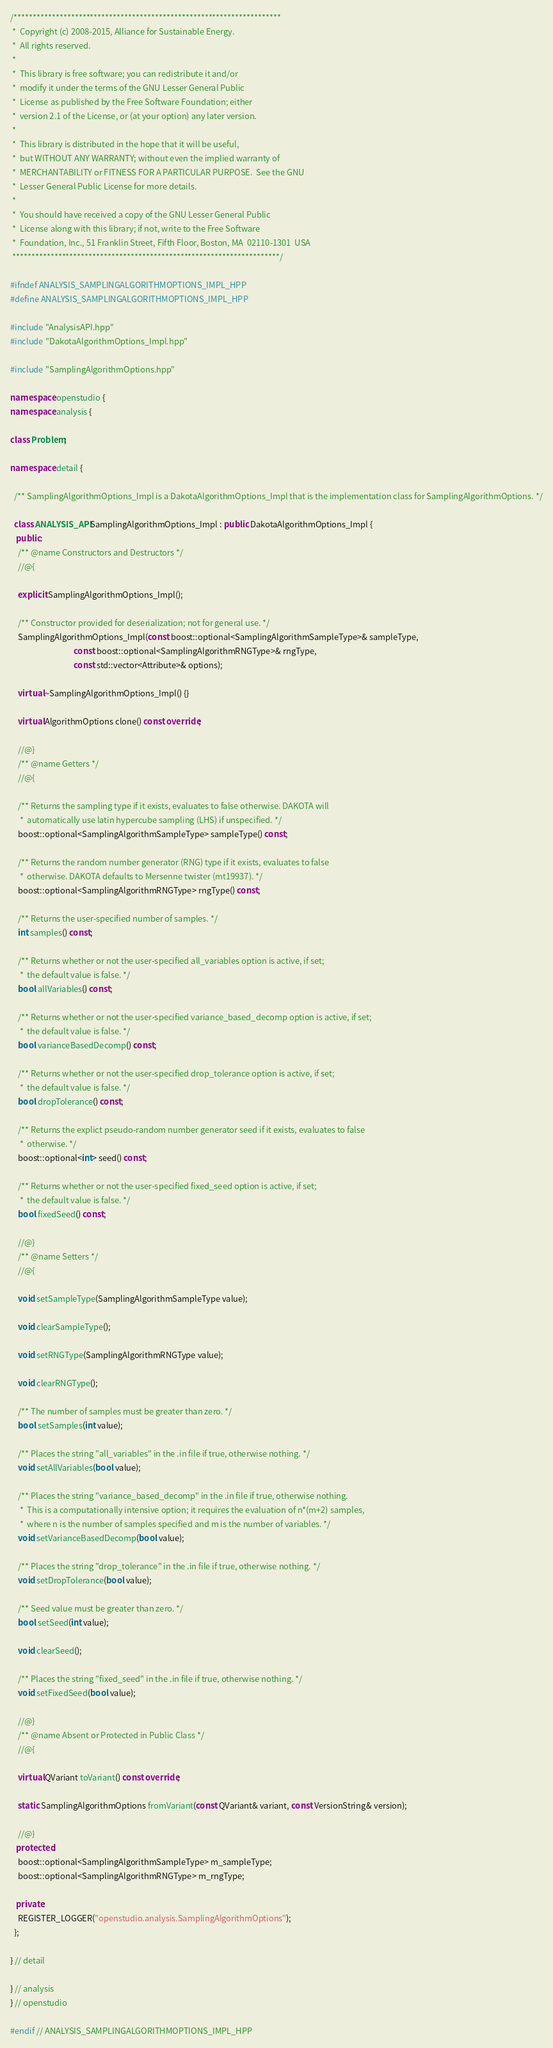<code> <loc_0><loc_0><loc_500><loc_500><_C++_>/**********************************************************************
 *  Copyright (c) 2008-2015, Alliance for Sustainable Energy.
 *  All rights reserved.
 *
 *  This library is free software; you can redistribute it and/or
 *  modify it under the terms of the GNU Lesser General Public
 *  License as published by the Free Software Foundation; either
 *  version 2.1 of the License, or (at your option) any later version.
 *
 *  This library is distributed in the hope that it will be useful,
 *  but WITHOUT ANY WARRANTY; without even the implied warranty of
 *  MERCHANTABILITY or FITNESS FOR A PARTICULAR PURPOSE.  See the GNU
 *  Lesser General Public License for more details.
 *
 *  You should have received a copy of the GNU Lesser General Public
 *  License along with this library; if not, write to the Free Software
 *  Foundation, Inc., 51 Franklin Street, Fifth Floor, Boston, MA  02110-1301  USA
 **********************************************************************/

#ifndef ANALYSIS_SAMPLINGALGORITHMOPTIONS_IMPL_HPP
#define ANALYSIS_SAMPLINGALGORITHMOPTIONS_IMPL_HPP

#include "AnalysisAPI.hpp"
#include "DakotaAlgorithmOptions_Impl.hpp"

#include "SamplingAlgorithmOptions.hpp"

namespace openstudio {
namespace analysis {

class Problem;

namespace detail {

  /** SamplingAlgorithmOptions_Impl is a DakotaAlgorithmOptions_Impl that is the implementation class for SamplingAlgorithmOptions. */

  class ANALYSIS_API SamplingAlgorithmOptions_Impl : public DakotaAlgorithmOptions_Impl {
   public:
    /** @name Constructors and Destructors */
    //@{

    explicit SamplingAlgorithmOptions_Impl();

    /** Constructor provided for deserialization; not for general use. */
    SamplingAlgorithmOptions_Impl(const boost::optional<SamplingAlgorithmSampleType>& sampleType,
                                  const boost::optional<SamplingAlgorithmRNGType>& rngType,
                                  const std::vector<Attribute>& options);

    virtual ~SamplingAlgorithmOptions_Impl() {}

    virtual AlgorithmOptions clone() const override;

    //@}
    /** @name Getters */
    //@{

    /** Returns the sampling type if it exists, evaluates to false otherwise. DAKOTA will 
     *  automatically use latin hypercube sampling (LHS) if unspecified. */
    boost::optional<SamplingAlgorithmSampleType> sampleType() const;

    /** Returns the random number generator (RNG) type if it exists, evaluates to false 
     *  otherwise. DAKOTA defaults to Mersenne twister (mt19937). */
    boost::optional<SamplingAlgorithmRNGType> rngType() const;

    /** Returns the user-specified number of samples. */
    int samples() const;

    /** Returns whether or not the user-specified all_variables option is active, if set;
     *  the default value is false. */
    bool allVariables() const;

    /** Returns whether or not the user-specified variance_based_decomp option is active, if set;
     *  the default value is false. */
    bool varianceBasedDecomp() const;

    /** Returns whether or not the user-specified drop_tolerance option is active, if set;
     *  the default value is false. */
    bool dropTolerance() const;

    /** Returns the explict pseudo-random number generator seed if it exists, evaluates to false 
     *  otherwise. */
    boost::optional<int> seed() const;

    /** Returns whether or not the user-specified fixed_seed option is active, if set;
     *  the default value is false. */
    bool fixedSeed() const;

    //@}
    /** @name Setters */
    //@{
  
    void setSampleType(SamplingAlgorithmSampleType value);
  
    void clearSampleType();   
  
    void setRNGType(SamplingAlgorithmRNGType value);
  
    void clearRNGType();   

    /** The number of samples must be greater than zero. */
    bool setSamples(int value);

    /** Places the string "all_variables" in the .in file if true, otherwise nothing. */
    void setAllVariables(bool value);
  
    /** Places the string "variance_based_decomp" in the .in file if true, otherwise nothing.
     *  This is a computationally intensive option; it requires the evaluation of n*(m+2) samples,
     *  where n is the number of samples specified and m is the number of variables. */
    void setVarianceBasedDecomp(bool value);

    /** Places the string "drop_tolerance" in the .in file if true, otherwise nothing. */
    void setDropTolerance(bool value);

    /** Seed value must be greater than zero. */
    bool setSeed(int value);
  
    void clearSeed();  

    /** Places the string "fixed_seed" in the .in file if true, otherwise nothing. */
    void setFixedSeed(bool value);

    //@}
    /** @name Absent or Protected in Public Class */
    //@{

    virtual QVariant toVariant() const override;

    static SamplingAlgorithmOptions fromVariant(const QVariant& variant, const VersionString& version);

    //@}
   protected:
    boost::optional<SamplingAlgorithmSampleType> m_sampleType;
    boost::optional<SamplingAlgorithmRNGType> m_rngType;

   private:
    REGISTER_LOGGER("openstudio.analysis.SamplingAlgorithmOptions");
  };

} // detail

} // analysis
} // openstudio

#endif // ANALYSIS_SAMPLINGALGORITHMOPTIONS_IMPL_HPP

</code> 